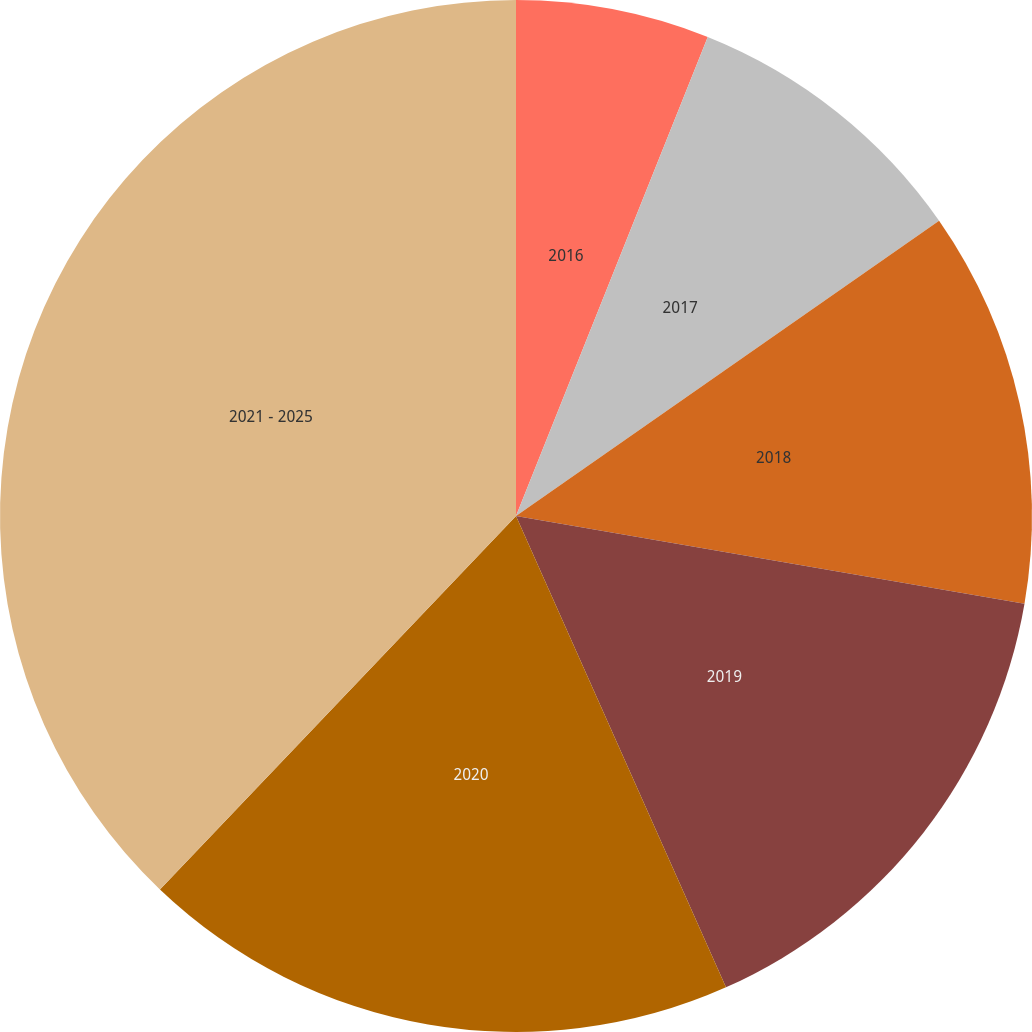<chart> <loc_0><loc_0><loc_500><loc_500><pie_chart><fcel>2016<fcel>2017<fcel>2018<fcel>2019<fcel>2020<fcel>2021 - 2025<nl><fcel>6.06%<fcel>9.24%<fcel>12.42%<fcel>15.61%<fcel>18.79%<fcel>37.88%<nl></chart> 